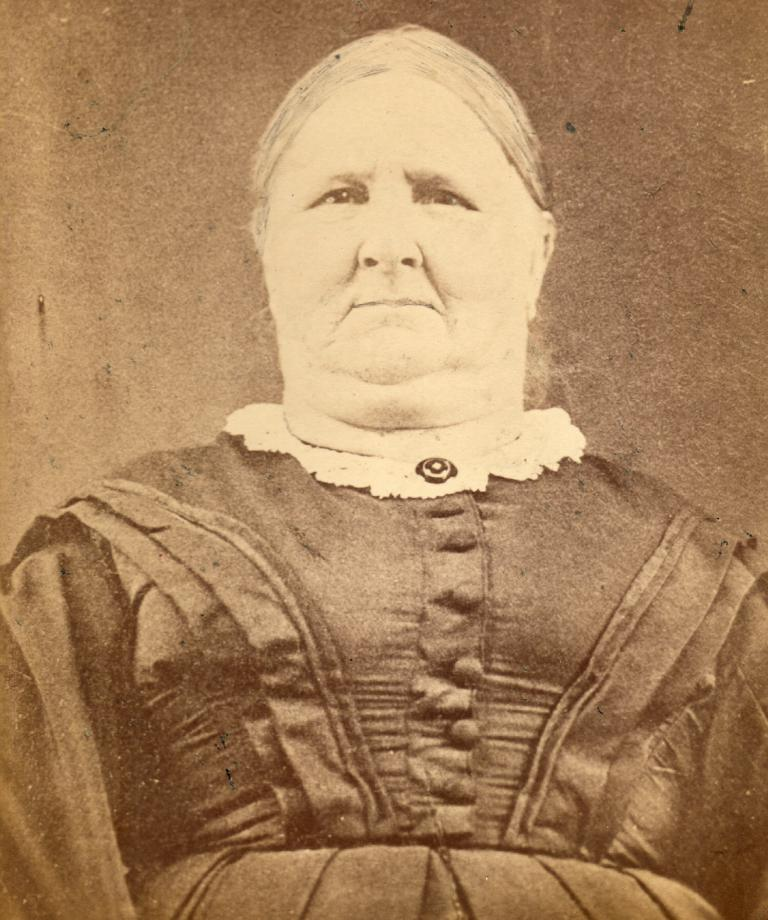What is the main subject of the image? There is a person standing in the image. What is the person wearing? The person is wearing a dress. What is the color scheme of the image? The image is in black and white. What type of holiday is being celebrated in the image? There is no indication of a holiday being celebrated in the image, as it only features a person standing in a black and white setting. Can you see any dinosaurs in the image? There are no dinosaurs present in the image. 